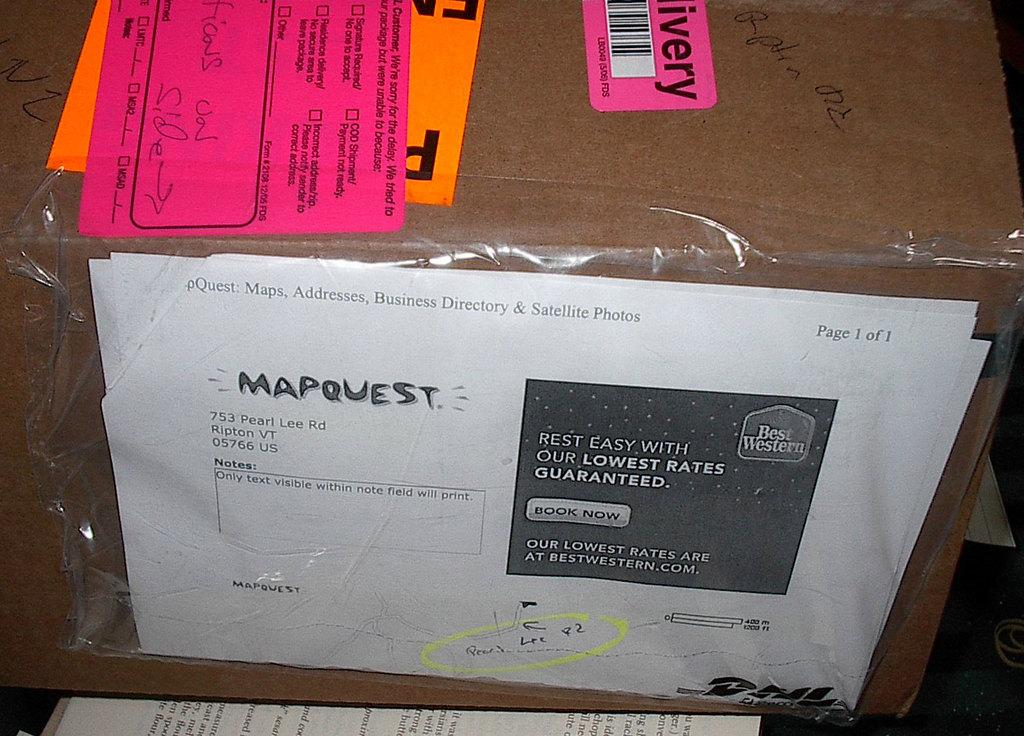<image>
Create a compact narrative representing the image presented. A package has a Mapquest paper taped to the side of it, which shows an address in Vermont. 